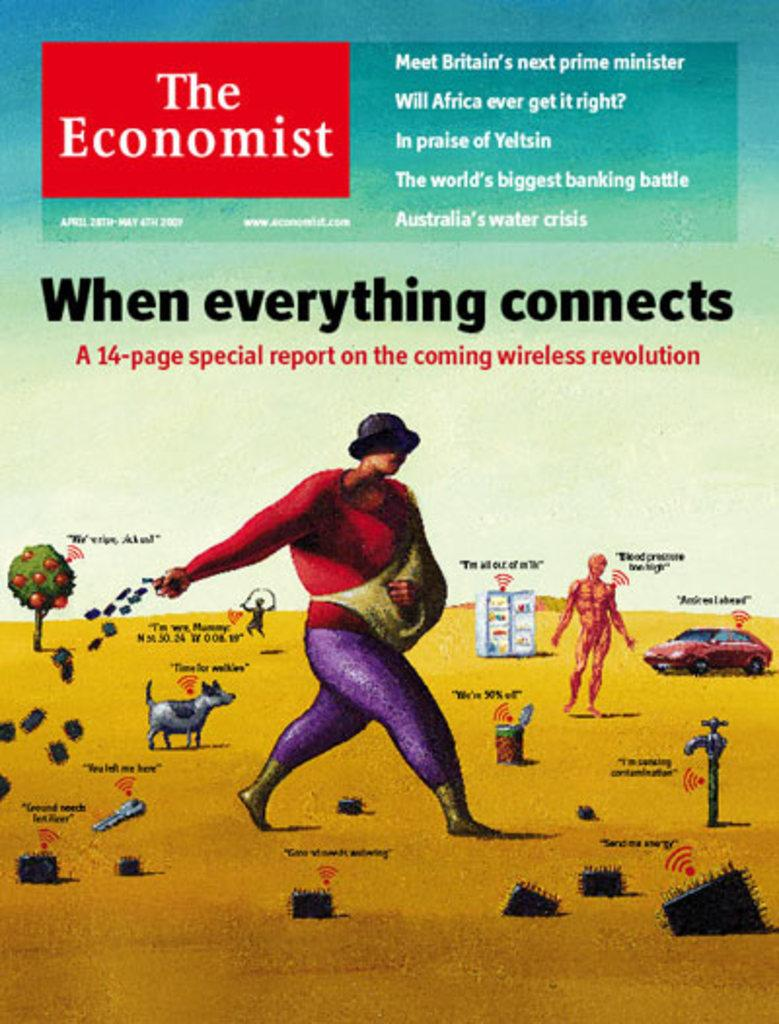Provide a one-sentence caption for the provided image. The economist poster that contains a fourteen page special report. 